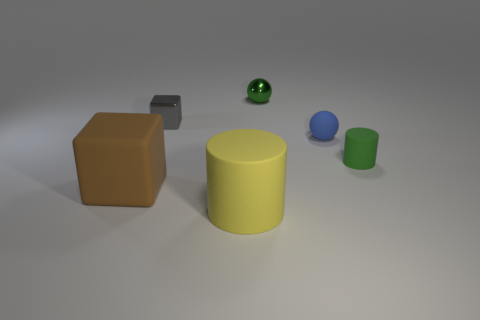Add 2 small metal things. How many objects exist? 8 Subtract all cubes. How many objects are left? 4 Subtract 0 brown balls. How many objects are left? 6 Subtract all yellow rubber cylinders. Subtract all large blue matte balls. How many objects are left? 5 Add 5 small green rubber cylinders. How many small green rubber cylinders are left? 6 Add 6 yellow rubber things. How many yellow rubber things exist? 7 